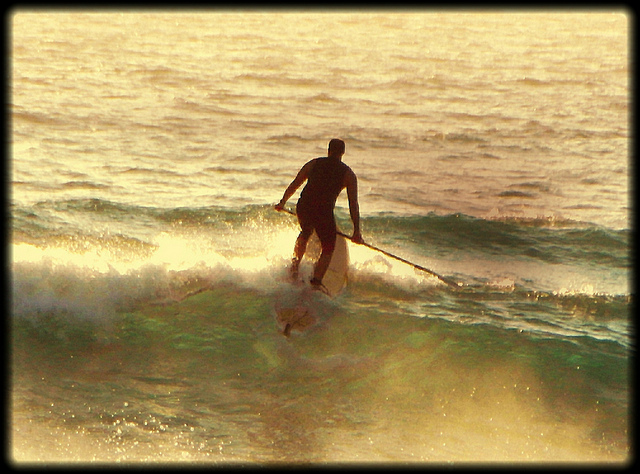What is the difference between surfing and stand-up paddleboarding? Surfing and stand-up paddleboarding (SUP) are both exciting water sports, yet they have distinct differences in technique and equipment. Surfing involves riding waves on a surfboard, relying on the wave's power to move forward, performing various maneuvers, and maintaining balance. Conversely, stand-up paddleboarding involves standing on a large, stable board and using a long paddle for propulsion, balance, and steering. While surfing typically happens on ocean waves, SUP can be enjoyed in a wider range of water types, including oceans, lakes, and rivers, offering a more versatile and often more relaxed experience. 